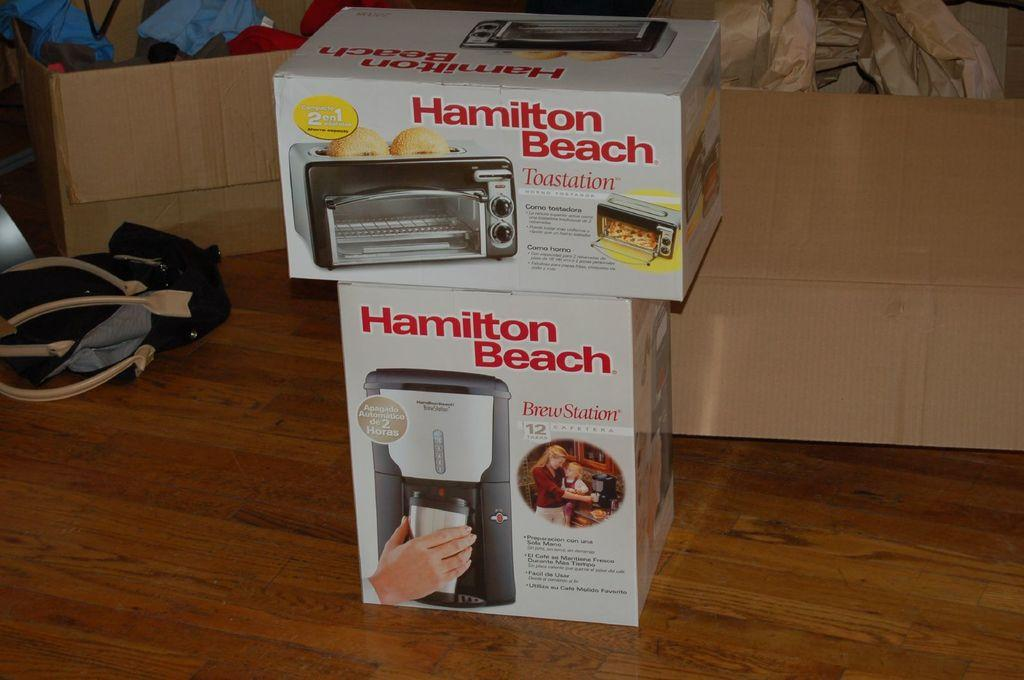<image>
Share a concise interpretation of the image provided. Two Hamilton Beach boxes stacked on top of one another a toastation and a Brewstation. 